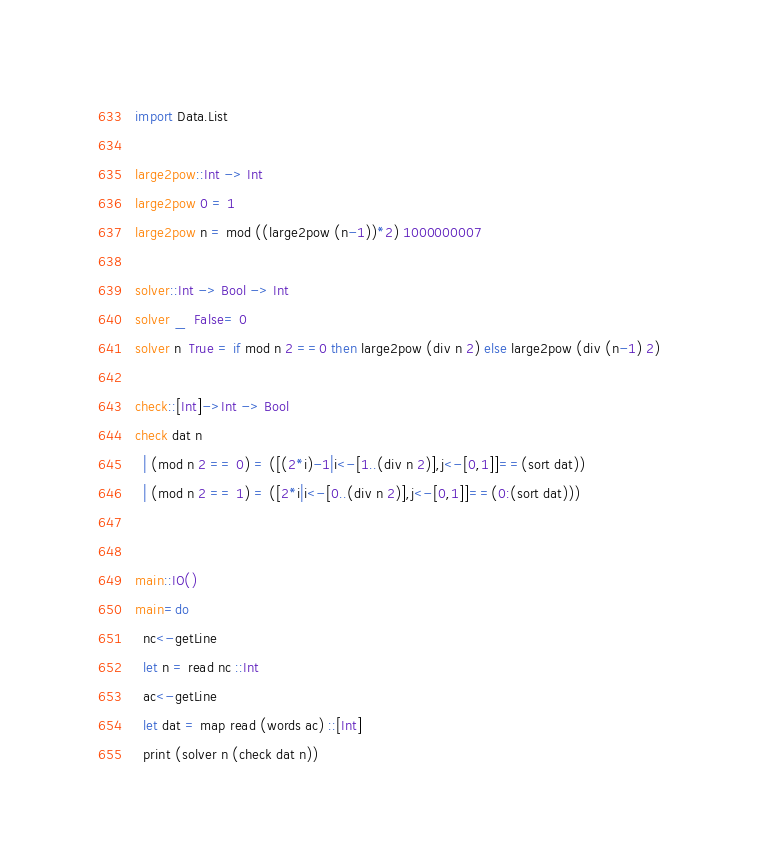<code> <loc_0><loc_0><loc_500><loc_500><_Haskell_>import Data.List

large2pow::Int -> Int
large2pow 0 = 1
large2pow n = mod ((large2pow (n-1))*2) 1000000007

solver::Int -> Bool -> Int
solver _  False= 0
solver n  True = if mod n 2 ==0 then large2pow (div n 2) else large2pow (div (n-1) 2)

check::[Int]->Int -> Bool
check dat n
  | (mod n 2 == 0) = ([(2*i)-1|i<-[1..(div n 2)],j<-[0,1]]==(sort dat))
  | (mod n 2 == 1) = ([2*i|i<-[0..(div n 2)],j<-[0,1]]==(0:(sort dat)))


main::IO()
main=do
  nc<-getLine
  let n = read nc ::Int
  ac<-getLine
  let dat = map read (words ac) ::[Int]
  print (solver n (check dat n))
</code> 